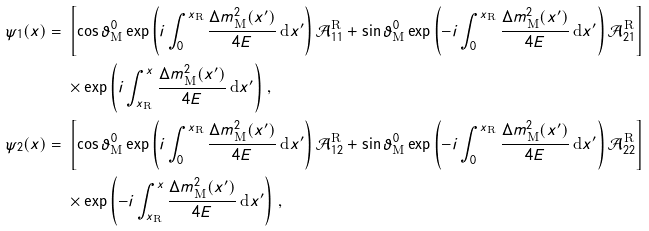<formula> <loc_0><loc_0><loc_500><loc_500>\psi _ { 1 } ( x ) = \null & \null \left [ \cos \vartheta _ { \text {M} } ^ { 0 } \exp \left ( i \int _ { 0 } ^ { x _ { \text {R} } } \frac { \Delta { m } ^ { 2 } _ { \text {M} } ( x ^ { \prime } ) } { 4 E } \, \text {d} x ^ { \prime } \right ) \mathcal { A } _ { 1 1 } ^ { \text {R} } + \sin \vartheta _ { \text {M} } ^ { 0 } \exp \left ( - i \int _ { 0 } ^ { x _ { \text {R} } } \frac { \Delta { m } ^ { 2 } _ { \text {M} } ( x ^ { \prime } ) } { 4 E } \, \text {d} x ^ { \prime } \right ) \mathcal { A } _ { 2 1 } ^ { \text {R} } \right ] \\ \null & \null \times \exp \left ( i \int _ { x _ { \text {R} } } ^ { x } \frac { \Delta { m } ^ { 2 } _ { \text {M} } ( x ^ { \prime } ) } { 4 E } \, \text {d} x ^ { \prime } \right ) \, , \\ \psi _ { 2 } ( x ) = \null & \null \left [ \cos \vartheta _ { \text {M} } ^ { 0 } \exp \left ( i \int _ { 0 } ^ { x _ { \text {R} } } \frac { \Delta { m } ^ { 2 } _ { \text {M} } ( x ^ { \prime } ) } { 4 E } \, \text {d} x ^ { \prime } \right ) \mathcal { A } _ { 1 2 } ^ { \text {R} } + \sin \vartheta _ { \text {M} } ^ { 0 } \exp \left ( - i \int _ { 0 } ^ { x _ { \text {R} } } \frac { \Delta { m } ^ { 2 } _ { \text {M} } ( x ^ { \prime } ) } { 4 E } \, \text {d} x ^ { \prime } \right ) \mathcal { A } _ { 2 2 } ^ { \text {R} } \right ] \\ \null & \null \times \exp \left ( - i \int _ { x _ { \text {R} } } ^ { x } \frac { \Delta { m } ^ { 2 } _ { \text {M} } ( x ^ { \prime } ) } { 4 E } \, \text {d} x ^ { \prime } \right ) \, ,</formula> 